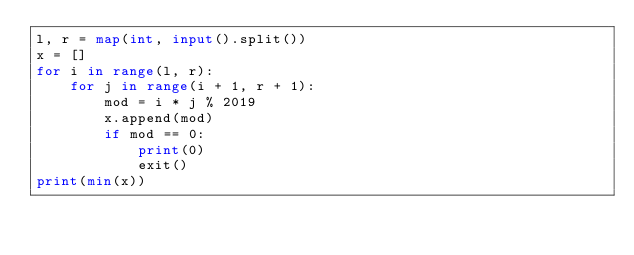Convert code to text. <code><loc_0><loc_0><loc_500><loc_500><_Python_>l, r = map(int, input().split())
x = []
for i in range(l, r):
    for j in range(i + 1, r + 1):
        mod = i * j % 2019
        x.append(mod)
        if mod == 0:
            print(0)
            exit()
print(min(x))</code> 